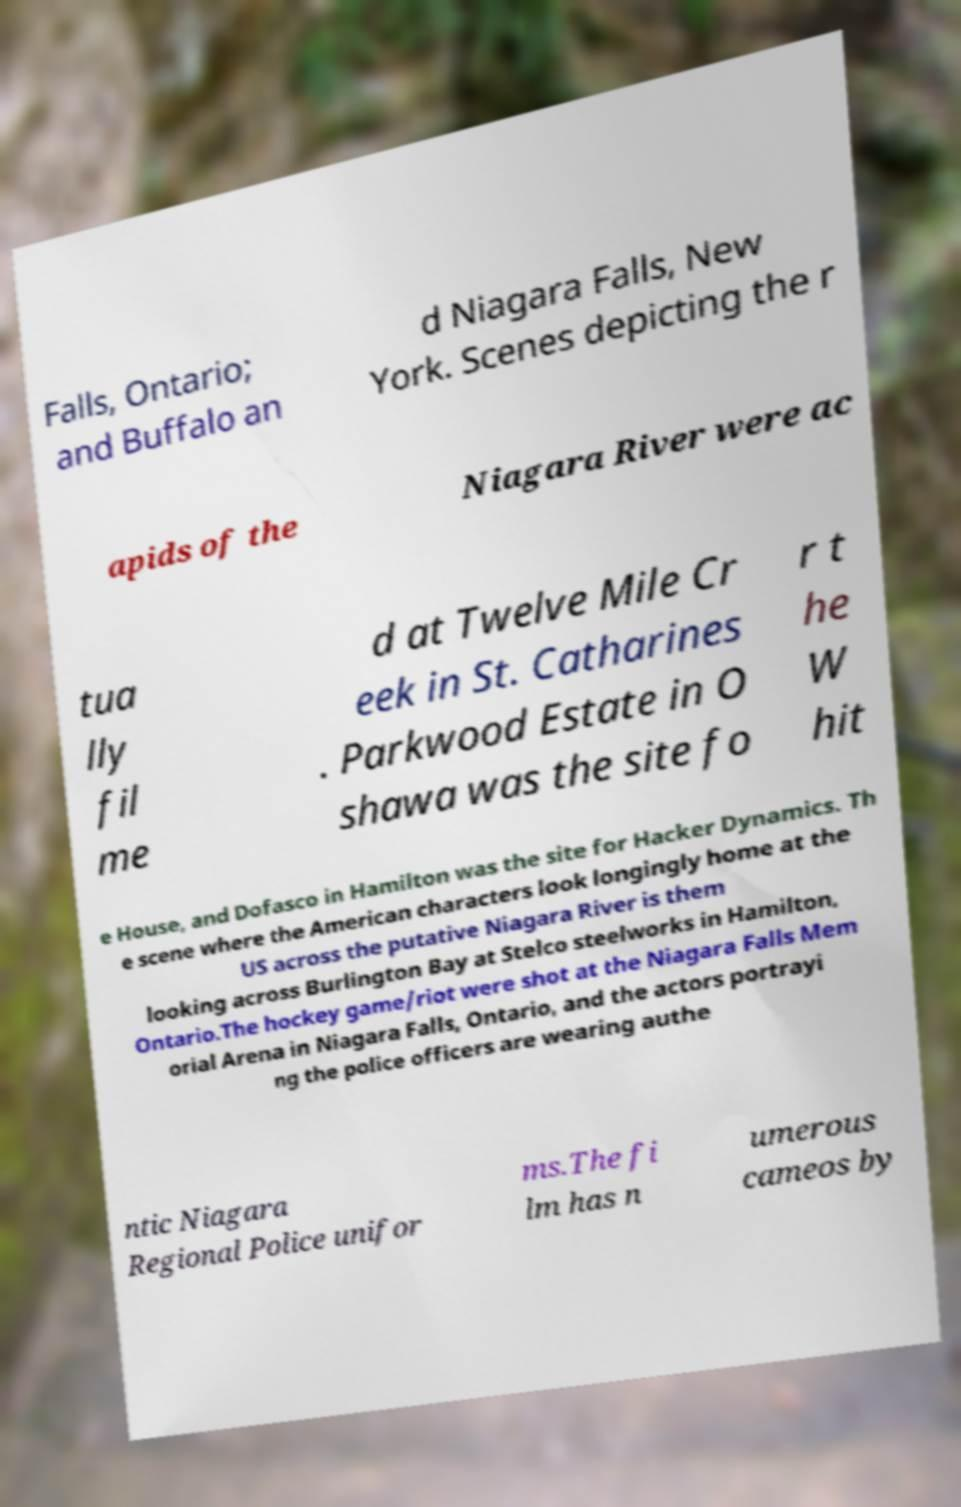For documentation purposes, I need the text within this image transcribed. Could you provide that? Falls, Ontario; and Buffalo an d Niagara Falls, New York. Scenes depicting the r apids of the Niagara River were ac tua lly fil me d at Twelve Mile Cr eek in St. Catharines . Parkwood Estate in O shawa was the site fo r t he W hit e House, and Dofasco in Hamilton was the site for Hacker Dynamics. Th e scene where the American characters look longingly home at the US across the putative Niagara River is them looking across Burlington Bay at Stelco steelworks in Hamilton, Ontario.The hockey game/riot were shot at the Niagara Falls Mem orial Arena in Niagara Falls, Ontario, and the actors portrayi ng the police officers are wearing authe ntic Niagara Regional Police unifor ms.The fi lm has n umerous cameos by 